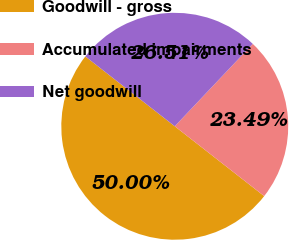<chart> <loc_0><loc_0><loc_500><loc_500><pie_chart><fcel>Goodwill - gross<fcel>Accumulated impairments<fcel>Net goodwill<nl><fcel>50.0%<fcel>23.49%<fcel>26.51%<nl></chart> 